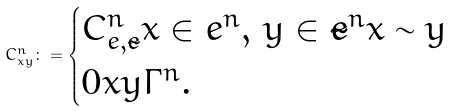<formula> <loc_0><loc_0><loc_500><loc_500>C ^ { n } _ { x y } \colon = \begin{cases} C ^ { n } _ { e , \tilde { e } } x \in e ^ { n } , \, y \in \tilde { e } ^ { n } x \sim y \\ 0 x y \Gamma ^ { n } . \end{cases}</formula> 